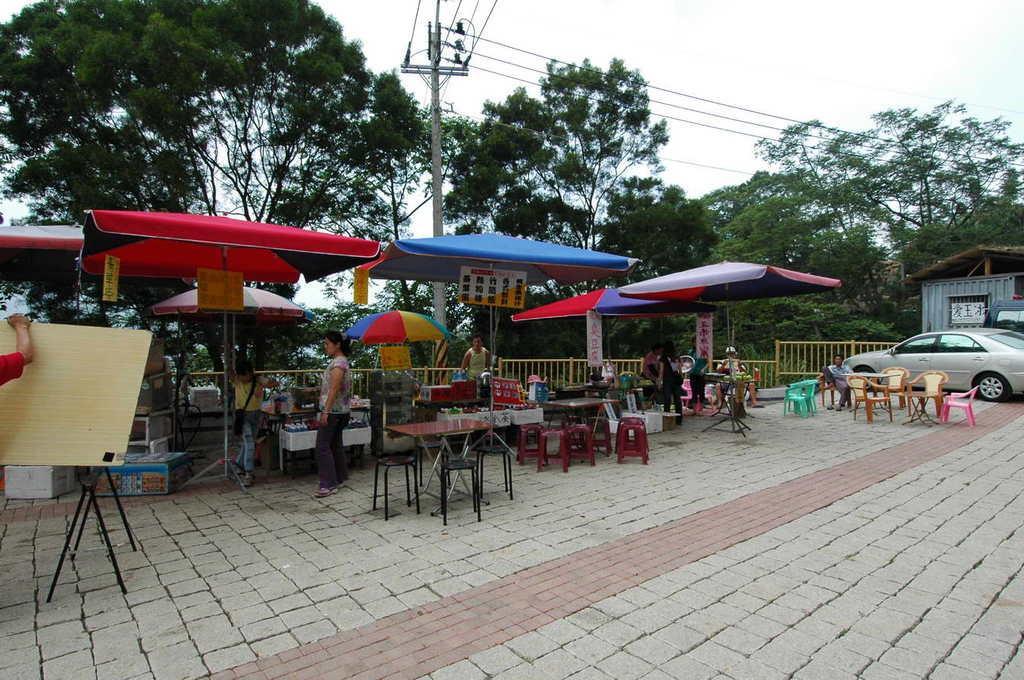How would you summarize this image in a sentence or two? In this picture we can see a person kept his hand on a wooden board. This wooden board is visible on the stand. We can see tables, chairs, boards, umbrellas and some colorful objects. There is a person sitting on a chair. We can see a few vehicles and a shed on the right side. Few wires are visible on a pole. There are some trees visible in the background. We can see the sky on top of the picture. 